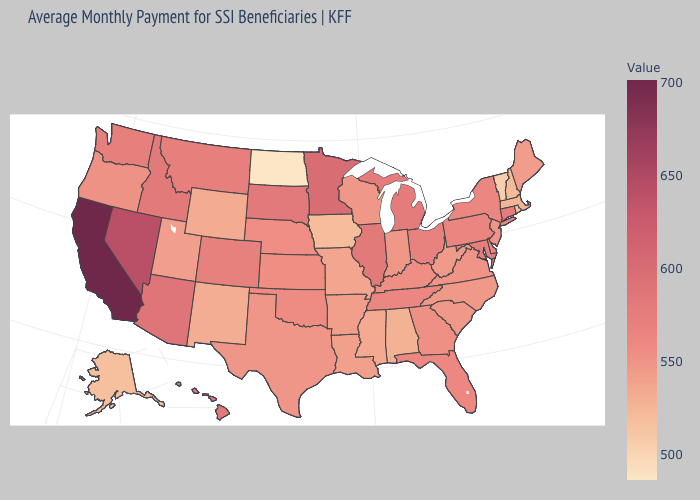Among the states that border Pennsylvania , which have the lowest value?
Answer briefly. West Virginia. Does New Mexico have the lowest value in the West?
Short answer required. No. Which states have the lowest value in the USA?
Quick response, please. North Dakota. Does California have the highest value in the USA?
Be succinct. Yes. 